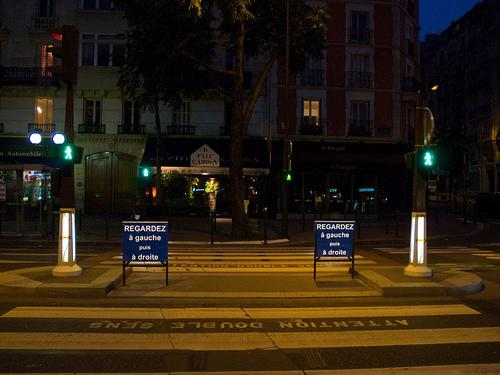What language is probably spoken in this locale? Please explain your reasoning. french. The signs are in the french language. 